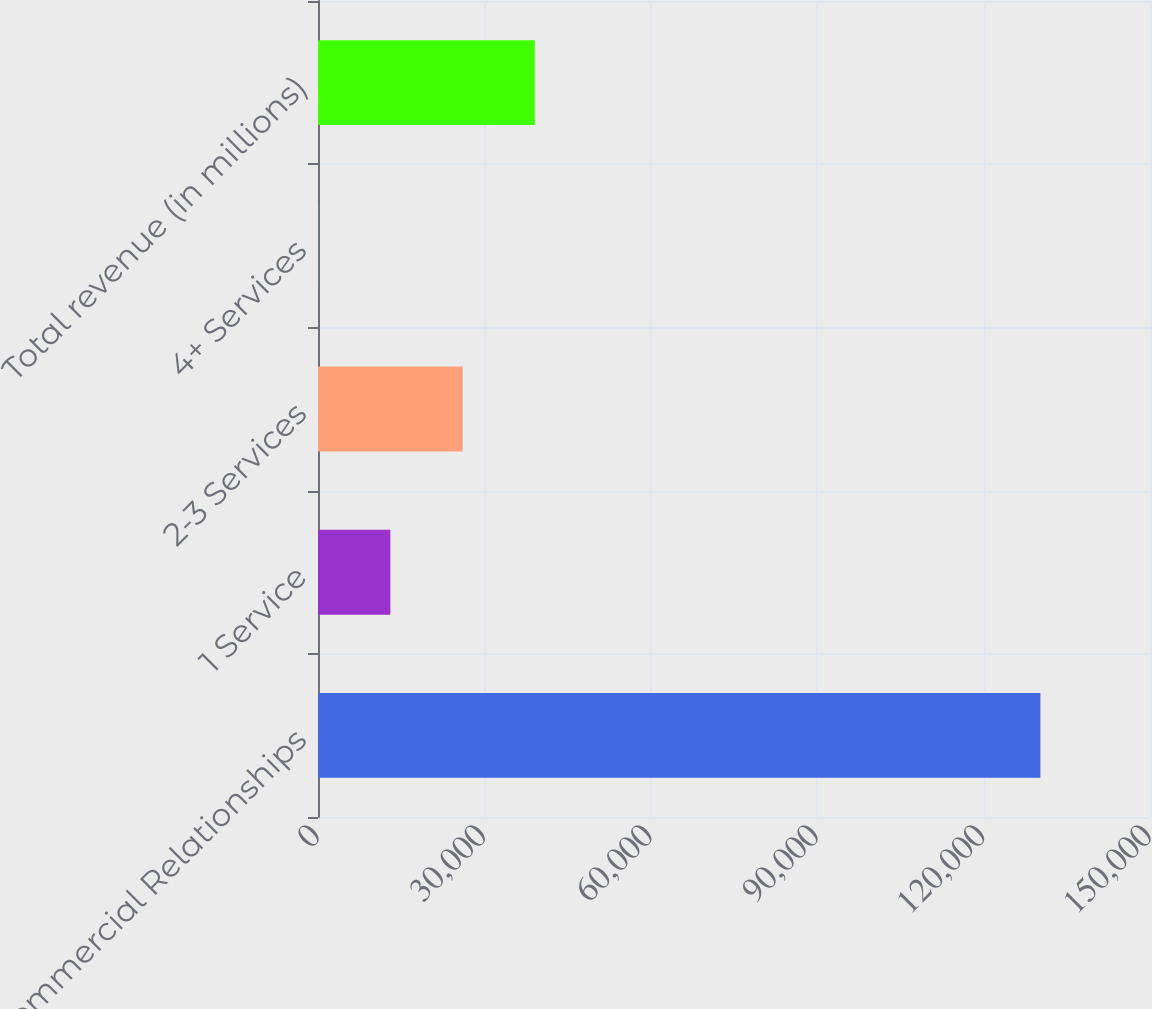<chart> <loc_0><loc_0><loc_500><loc_500><bar_chart><fcel>Commercial Relationships<fcel>1 Service<fcel>2-3 Services<fcel>4+ Services<fcel>Total revenue (in millions)<nl><fcel>130240<fcel>13046.9<fcel>26068.3<fcel>25.4<fcel>39089.8<nl></chart> 